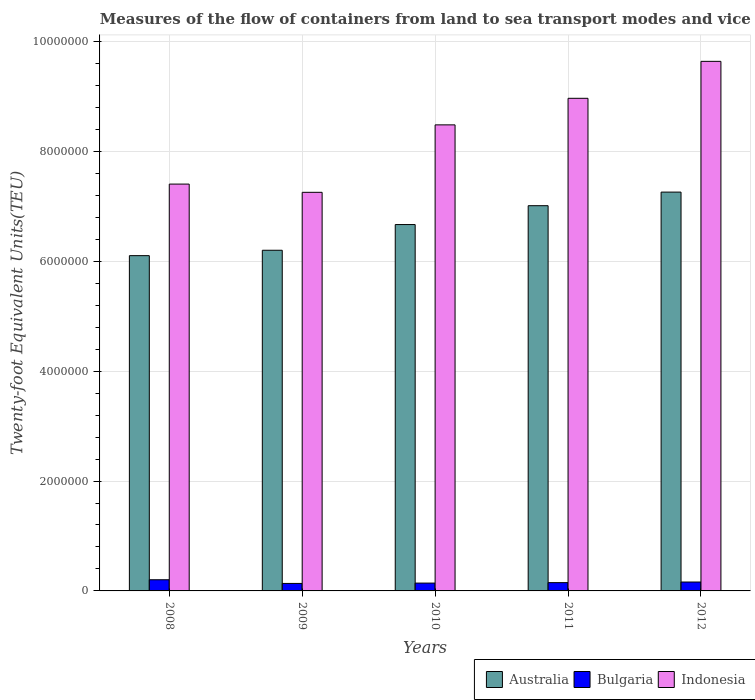Are the number of bars per tick equal to the number of legend labels?
Your response must be concise. Yes. How many bars are there on the 2nd tick from the right?
Your answer should be very brief. 3. In how many cases, is the number of bars for a given year not equal to the number of legend labels?
Your answer should be compact. 0. What is the container port traffic in Australia in 2010?
Your answer should be compact. 6.67e+06. Across all years, what is the maximum container port traffic in Australia?
Give a very brief answer. 7.26e+06. Across all years, what is the minimum container port traffic in Indonesia?
Make the answer very short. 7.26e+06. What is the total container port traffic in Australia in the graph?
Make the answer very short. 3.32e+07. What is the difference between the container port traffic in Australia in 2009 and that in 2012?
Keep it short and to the point. -1.06e+06. What is the difference between the container port traffic in Indonesia in 2011 and the container port traffic in Bulgaria in 2009?
Make the answer very short. 8.83e+06. What is the average container port traffic in Bulgaria per year?
Your response must be concise. 1.59e+05. In the year 2008, what is the difference between the container port traffic in Bulgaria and container port traffic in Indonesia?
Ensure brevity in your answer.  -7.20e+06. In how many years, is the container port traffic in Indonesia greater than 7600000 TEU?
Your answer should be compact. 3. What is the ratio of the container port traffic in Australia in 2008 to that in 2012?
Provide a short and direct response. 0.84. Is the difference between the container port traffic in Bulgaria in 2009 and 2012 greater than the difference between the container port traffic in Indonesia in 2009 and 2012?
Your response must be concise. Yes. What is the difference between the highest and the second highest container port traffic in Australia?
Give a very brief answer. 2.47e+05. What is the difference between the highest and the lowest container port traffic in Bulgaria?
Your response must be concise. 6.68e+04. In how many years, is the container port traffic in Australia greater than the average container port traffic in Australia taken over all years?
Keep it short and to the point. 3. Is the sum of the container port traffic in Indonesia in 2008 and 2010 greater than the maximum container port traffic in Bulgaria across all years?
Give a very brief answer. Yes. Is it the case that in every year, the sum of the container port traffic in Indonesia and container port traffic in Bulgaria is greater than the container port traffic in Australia?
Make the answer very short. Yes. How many bars are there?
Provide a short and direct response. 15. Are all the bars in the graph horizontal?
Provide a short and direct response. No. How many years are there in the graph?
Provide a short and direct response. 5. What is the difference between two consecutive major ticks on the Y-axis?
Your answer should be compact. 2.00e+06. Does the graph contain any zero values?
Provide a short and direct response. No. Does the graph contain grids?
Keep it short and to the point. Yes. What is the title of the graph?
Give a very brief answer. Measures of the flow of containers from land to sea transport modes and vice versa. Does "Somalia" appear as one of the legend labels in the graph?
Keep it short and to the point. No. What is the label or title of the X-axis?
Give a very brief answer. Years. What is the label or title of the Y-axis?
Make the answer very short. Twenty-foot Equivalent Units(TEU). What is the Twenty-foot Equivalent Units(TEU) of Australia in 2008?
Keep it short and to the point. 6.10e+06. What is the Twenty-foot Equivalent Units(TEU) of Bulgaria in 2008?
Your answer should be compact. 2.03e+05. What is the Twenty-foot Equivalent Units(TEU) of Indonesia in 2008?
Your answer should be compact. 7.40e+06. What is the Twenty-foot Equivalent Units(TEU) of Australia in 2009?
Keep it short and to the point. 6.20e+06. What is the Twenty-foot Equivalent Units(TEU) in Bulgaria in 2009?
Your answer should be very brief. 1.36e+05. What is the Twenty-foot Equivalent Units(TEU) in Indonesia in 2009?
Offer a very short reply. 7.26e+06. What is the Twenty-foot Equivalent Units(TEU) in Australia in 2010?
Keep it short and to the point. 6.67e+06. What is the Twenty-foot Equivalent Units(TEU) in Bulgaria in 2010?
Your answer should be very brief. 1.43e+05. What is the Twenty-foot Equivalent Units(TEU) of Indonesia in 2010?
Provide a succinct answer. 8.48e+06. What is the Twenty-foot Equivalent Units(TEU) of Australia in 2011?
Offer a very short reply. 7.01e+06. What is the Twenty-foot Equivalent Units(TEU) of Bulgaria in 2011?
Your response must be concise. 1.51e+05. What is the Twenty-foot Equivalent Units(TEU) of Indonesia in 2011?
Provide a succinct answer. 8.97e+06. What is the Twenty-foot Equivalent Units(TEU) of Australia in 2012?
Provide a short and direct response. 7.26e+06. What is the Twenty-foot Equivalent Units(TEU) of Bulgaria in 2012?
Offer a terse response. 1.62e+05. What is the Twenty-foot Equivalent Units(TEU) of Indonesia in 2012?
Make the answer very short. 9.64e+06. Across all years, what is the maximum Twenty-foot Equivalent Units(TEU) of Australia?
Offer a terse response. 7.26e+06. Across all years, what is the maximum Twenty-foot Equivalent Units(TEU) of Bulgaria?
Provide a succinct answer. 2.03e+05. Across all years, what is the maximum Twenty-foot Equivalent Units(TEU) in Indonesia?
Your answer should be very brief. 9.64e+06. Across all years, what is the minimum Twenty-foot Equivalent Units(TEU) of Australia?
Your response must be concise. 6.10e+06. Across all years, what is the minimum Twenty-foot Equivalent Units(TEU) of Bulgaria?
Give a very brief answer. 1.36e+05. Across all years, what is the minimum Twenty-foot Equivalent Units(TEU) of Indonesia?
Provide a succinct answer. 7.26e+06. What is the total Twenty-foot Equivalent Units(TEU) of Australia in the graph?
Make the answer very short. 3.32e+07. What is the total Twenty-foot Equivalent Units(TEU) of Bulgaria in the graph?
Offer a terse response. 7.95e+05. What is the total Twenty-foot Equivalent Units(TEU) of Indonesia in the graph?
Offer a terse response. 4.17e+07. What is the difference between the Twenty-foot Equivalent Units(TEU) in Australia in 2008 and that in 2009?
Offer a terse response. -9.80e+04. What is the difference between the Twenty-foot Equivalent Units(TEU) of Bulgaria in 2008 and that in 2009?
Provide a short and direct response. 6.68e+04. What is the difference between the Twenty-foot Equivalent Units(TEU) in Indonesia in 2008 and that in 2009?
Offer a very short reply. 1.50e+05. What is the difference between the Twenty-foot Equivalent Units(TEU) in Australia in 2008 and that in 2010?
Your answer should be compact. -5.66e+05. What is the difference between the Twenty-foot Equivalent Units(TEU) in Bulgaria in 2008 and that in 2010?
Keep it short and to the point. 6.06e+04. What is the difference between the Twenty-foot Equivalent Units(TEU) of Indonesia in 2008 and that in 2010?
Provide a succinct answer. -1.08e+06. What is the difference between the Twenty-foot Equivalent Units(TEU) in Australia in 2008 and that in 2011?
Keep it short and to the point. -9.09e+05. What is the difference between the Twenty-foot Equivalent Units(TEU) of Bulgaria in 2008 and that in 2011?
Make the answer very short. 5.25e+04. What is the difference between the Twenty-foot Equivalent Units(TEU) in Indonesia in 2008 and that in 2011?
Keep it short and to the point. -1.56e+06. What is the difference between the Twenty-foot Equivalent Units(TEU) in Australia in 2008 and that in 2012?
Make the answer very short. -1.16e+06. What is the difference between the Twenty-foot Equivalent Units(TEU) of Bulgaria in 2008 and that in 2012?
Make the answer very short. 4.12e+04. What is the difference between the Twenty-foot Equivalent Units(TEU) in Indonesia in 2008 and that in 2012?
Provide a succinct answer. -2.23e+06. What is the difference between the Twenty-foot Equivalent Units(TEU) of Australia in 2009 and that in 2010?
Give a very brief answer. -4.68e+05. What is the difference between the Twenty-foot Equivalent Units(TEU) in Bulgaria in 2009 and that in 2010?
Provide a succinct answer. -6167. What is the difference between the Twenty-foot Equivalent Units(TEU) in Indonesia in 2009 and that in 2010?
Offer a terse response. -1.23e+06. What is the difference between the Twenty-foot Equivalent Units(TEU) of Australia in 2009 and that in 2011?
Keep it short and to the point. -8.11e+05. What is the difference between the Twenty-foot Equivalent Units(TEU) in Bulgaria in 2009 and that in 2011?
Provide a succinct answer. -1.43e+04. What is the difference between the Twenty-foot Equivalent Units(TEU) in Indonesia in 2009 and that in 2011?
Ensure brevity in your answer.  -1.71e+06. What is the difference between the Twenty-foot Equivalent Units(TEU) of Australia in 2009 and that in 2012?
Offer a very short reply. -1.06e+06. What is the difference between the Twenty-foot Equivalent Units(TEU) of Bulgaria in 2009 and that in 2012?
Offer a terse response. -2.56e+04. What is the difference between the Twenty-foot Equivalent Units(TEU) in Indonesia in 2009 and that in 2012?
Give a very brief answer. -2.38e+06. What is the difference between the Twenty-foot Equivalent Units(TEU) of Australia in 2010 and that in 2011?
Provide a short and direct response. -3.44e+05. What is the difference between the Twenty-foot Equivalent Units(TEU) of Bulgaria in 2010 and that in 2011?
Give a very brief answer. -8128.83. What is the difference between the Twenty-foot Equivalent Units(TEU) of Indonesia in 2010 and that in 2011?
Provide a succinct answer. -4.84e+05. What is the difference between the Twenty-foot Equivalent Units(TEU) in Australia in 2010 and that in 2012?
Your answer should be very brief. -5.91e+05. What is the difference between the Twenty-foot Equivalent Units(TEU) in Bulgaria in 2010 and that in 2012?
Your answer should be compact. -1.94e+04. What is the difference between the Twenty-foot Equivalent Units(TEU) of Indonesia in 2010 and that in 2012?
Provide a short and direct response. -1.16e+06. What is the difference between the Twenty-foot Equivalent Units(TEU) of Australia in 2011 and that in 2012?
Your response must be concise. -2.47e+05. What is the difference between the Twenty-foot Equivalent Units(TEU) of Bulgaria in 2011 and that in 2012?
Your answer should be compact. -1.13e+04. What is the difference between the Twenty-foot Equivalent Units(TEU) of Indonesia in 2011 and that in 2012?
Make the answer very short. -6.72e+05. What is the difference between the Twenty-foot Equivalent Units(TEU) of Australia in 2008 and the Twenty-foot Equivalent Units(TEU) of Bulgaria in 2009?
Your response must be concise. 5.97e+06. What is the difference between the Twenty-foot Equivalent Units(TEU) in Australia in 2008 and the Twenty-foot Equivalent Units(TEU) in Indonesia in 2009?
Your answer should be very brief. -1.15e+06. What is the difference between the Twenty-foot Equivalent Units(TEU) of Bulgaria in 2008 and the Twenty-foot Equivalent Units(TEU) of Indonesia in 2009?
Ensure brevity in your answer.  -7.05e+06. What is the difference between the Twenty-foot Equivalent Units(TEU) of Australia in 2008 and the Twenty-foot Equivalent Units(TEU) of Bulgaria in 2010?
Give a very brief answer. 5.96e+06. What is the difference between the Twenty-foot Equivalent Units(TEU) of Australia in 2008 and the Twenty-foot Equivalent Units(TEU) of Indonesia in 2010?
Provide a short and direct response. -2.38e+06. What is the difference between the Twenty-foot Equivalent Units(TEU) in Bulgaria in 2008 and the Twenty-foot Equivalent Units(TEU) in Indonesia in 2010?
Keep it short and to the point. -8.28e+06. What is the difference between the Twenty-foot Equivalent Units(TEU) in Australia in 2008 and the Twenty-foot Equivalent Units(TEU) in Bulgaria in 2011?
Make the answer very short. 5.95e+06. What is the difference between the Twenty-foot Equivalent Units(TEU) in Australia in 2008 and the Twenty-foot Equivalent Units(TEU) in Indonesia in 2011?
Give a very brief answer. -2.86e+06. What is the difference between the Twenty-foot Equivalent Units(TEU) in Bulgaria in 2008 and the Twenty-foot Equivalent Units(TEU) in Indonesia in 2011?
Provide a short and direct response. -8.76e+06. What is the difference between the Twenty-foot Equivalent Units(TEU) in Australia in 2008 and the Twenty-foot Equivalent Units(TEU) in Bulgaria in 2012?
Provide a succinct answer. 5.94e+06. What is the difference between the Twenty-foot Equivalent Units(TEU) in Australia in 2008 and the Twenty-foot Equivalent Units(TEU) in Indonesia in 2012?
Give a very brief answer. -3.54e+06. What is the difference between the Twenty-foot Equivalent Units(TEU) in Bulgaria in 2008 and the Twenty-foot Equivalent Units(TEU) in Indonesia in 2012?
Give a very brief answer. -9.44e+06. What is the difference between the Twenty-foot Equivalent Units(TEU) of Australia in 2009 and the Twenty-foot Equivalent Units(TEU) of Bulgaria in 2010?
Offer a terse response. 6.06e+06. What is the difference between the Twenty-foot Equivalent Units(TEU) in Australia in 2009 and the Twenty-foot Equivalent Units(TEU) in Indonesia in 2010?
Provide a succinct answer. -2.28e+06. What is the difference between the Twenty-foot Equivalent Units(TEU) in Bulgaria in 2009 and the Twenty-foot Equivalent Units(TEU) in Indonesia in 2010?
Your answer should be very brief. -8.35e+06. What is the difference between the Twenty-foot Equivalent Units(TEU) of Australia in 2009 and the Twenty-foot Equivalent Units(TEU) of Bulgaria in 2011?
Offer a very short reply. 6.05e+06. What is the difference between the Twenty-foot Equivalent Units(TEU) of Australia in 2009 and the Twenty-foot Equivalent Units(TEU) of Indonesia in 2011?
Your response must be concise. -2.77e+06. What is the difference between the Twenty-foot Equivalent Units(TEU) of Bulgaria in 2009 and the Twenty-foot Equivalent Units(TEU) of Indonesia in 2011?
Provide a succinct answer. -8.83e+06. What is the difference between the Twenty-foot Equivalent Units(TEU) of Australia in 2009 and the Twenty-foot Equivalent Units(TEU) of Bulgaria in 2012?
Ensure brevity in your answer.  6.04e+06. What is the difference between the Twenty-foot Equivalent Units(TEU) in Australia in 2009 and the Twenty-foot Equivalent Units(TEU) in Indonesia in 2012?
Provide a short and direct response. -3.44e+06. What is the difference between the Twenty-foot Equivalent Units(TEU) of Bulgaria in 2009 and the Twenty-foot Equivalent Units(TEU) of Indonesia in 2012?
Give a very brief answer. -9.50e+06. What is the difference between the Twenty-foot Equivalent Units(TEU) in Australia in 2010 and the Twenty-foot Equivalent Units(TEU) in Bulgaria in 2011?
Provide a succinct answer. 6.52e+06. What is the difference between the Twenty-foot Equivalent Units(TEU) of Australia in 2010 and the Twenty-foot Equivalent Units(TEU) of Indonesia in 2011?
Your answer should be compact. -2.30e+06. What is the difference between the Twenty-foot Equivalent Units(TEU) of Bulgaria in 2010 and the Twenty-foot Equivalent Units(TEU) of Indonesia in 2011?
Your answer should be compact. -8.82e+06. What is the difference between the Twenty-foot Equivalent Units(TEU) in Australia in 2010 and the Twenty-foot Equivalent Units(TEU) in Bulgaria in 2012?
Ensure brevity in your answer.  6.51e+06. What is the difference between the Twenty-foot Equivalent Units(TEU) in Australia in 2010 and the Twenty-foot Equivalent Units(TEU) in Indonesia in 2012?
Your response must be concise. -2.97e+06. What is the difference between the Twenty-foot Equivalent Units(TEU) in Bulgaria in 2010 and the Twenty-foot Equivalent Units(TEU) in Indonesia in 2012?
Ensure brevity in your answer.  -9.50e+06. What is the difference between the Twenty-foot Equivalent Units(TEU) in Australia in 2011 and the Twenty-foot Equivalent Units(TEU) in Bulgaria in 2012?
Your response must be concise. 6.85e+06. What is the difference between the Twenty-foot Equivalent Units(TEU) of Australia in 2011 and the Twenty-foot Equivalent Units(TEU) of Indonesia in 2012?
Your response must be concise. -2.63e+06. What is the difference between the Twenty-foot Equivalent Units(TEU) of Bulgaria in 2011 and the Twenty-foot Equivalent Units(TEU) of Indonesia in 2012?
Your response must be concise. -9.49e+06. What is the average Twenty-foot Equivalent Units(TEU) of Australia per year?
Your answer should be compact. 6.65e+06. What is the average Twenty-foot Equivalent Units(TEU) in Bulgaria per year?
Your answer should be very brief. 1.59e+05. What is the average Twenty-foot Equivalent Units(TEU) in Indonesia per year?
Your answer should be compact. 8.35e+06. In the year 2008, what is the difference between the Twenty-foot Equivalent Units(TEU) in Australia and Twenty-foot Equivalent Units(TEU) in Bulgaria?
Give a very brief answer. 5.90e+06. In the year 2008, what is the difference between the Twenty-foot Equivalent Units(TEU) of Australia and Twenty-foot Equivalent Units(TEU) of Indonesia?
Provide a short and direct response. -1.30e+06. In the year 2008, what is the difference between the Twenty-foot Equivalent Units(TEU) of Bulgaria and Twenty-foot Equivalent Units(TEU) of Indonesia?
Your response must be concise. -7.20e+06. In the year 2009, what is the difference between the Twenty-foot Equivalent Units(TEU) in Australia and Twenty-foot Equivalent Units(TEU) in Bulgaria?
Your answer should be compact. 6.06e+06. In the year 2009, what is the difference between the Twenty-foot Equivalent Units(TEU) of Australia and Twenty-foot Equivalent Units(TEU) of Indonesia?
Offer a terse response. -1.05e+06. In the year 2009, what is the difference between the Twenty-foot Equivalent Units(TEU) of Bulgaria and Twenty-foot Equivalent Units(TEU) of Indonesia?
Offer a very short reply. -7.12e+06. In the year 2010, what is the difference between the Twenty-foot Equivalent Units(TEU) of Australia and Twenty-foot Equivalent Units(TEU) of Bulgaria?
Offer a very short reply. 6.53e+06. In the year 2010, what is the difference between the Twenty-foot Equivalent Units(TEU) of Australia and Twenty-foot Equivalent Units(TEU) of Indonesia?
Provide a short and direct response. -1.81e+06. In the year 2010, what is the difference between the Twenty-foot Equivalent Units(TEU) of Bulgaria and Twenty-foot Equivalent Units(TEU) of Indonesia?
Provide a short and direct response. -8.34e+06. In the year 2011, what is the difference between the Twenty-foot Equivalent Units(TEU) in Australia and Twenty-foot Equivalent Units(TEU) in Bulgaria?
Your answer should be very brief. 6.86e+06. In the year 2011, what is the difference between the Twenty-foot Equivalent Units(TEU) of Australia and Twenty-foot Equivalent Units(TEU) of Indonesia?
Your answer should be very brief. -1.95e+06. In the year 2011, what is the difference between the Twenty-foot Equivalent Units(TEU) in Bulgaria and Twenty-foot Equivalent Units(TEU) in Indonesia?
Keep it short and to the point. -8.82e+06. In the year 2012, what is the difference between the Twenty-foot Equivalent Units(TEU) in Australia and Twenty-foot Equivalent Units(TEU) in Bulgaria?
Your response must be concise. 7.10e+06. In the year 2012, what is the difference between the Twenty-foot Equivalent Units(TEU) in Australia and Twenty-foot Equivalent Units(TEU) in Indonesia?
Keep it short and to the point. -2.38e+06. In the year 2012, what is the difference between the Twenty-foot Equivalent Units(TEU) of Bulgaria and Twenty-foot Equivalent Units(TEU) of Indonesia?
Your response must be concise. -9.48e+06. What is the ratio of the Twenty-foot Equivalent Units(TEU) of Australia in 2008 to that in 2009?
Give a very brief answer. 0.98. What is the ratio of the Twenty-foot Equivalent Units(TEU) of Bulgaria in 2008 to that in 2009?
Give a very brief answer. 1.49. What is the ratio of the Twenty-foot Equivalent Units(TEU) in Indonesia in 2008 to that in 2009?
Make the answer very short. 1.02. What is the ratio of the Twenty-foot Equivalent Units(TEU) in Australia in 2008 to that in 2010?
Provide a succinct answer. 0.92. What is the ratio of the Twenty-foot Equivalent Units(TEU) in Bulgaria in 2008 to that in 2010?
Your answer should be very brief. 1.43. What is the ratio of the Twenty-foot Equivalent Units(TEU) of Indonesia in 2008 to that in 2010?
Your response must be concise. 0.87. What is the ratio of the Twenty-foot Equivalent Units(TEU) of Australia in 2008 to that in 2011?
Ensure brevity in your answer.  0.87. What is the ratio of the Twenty-foot Equivalent Units(TEU) of Bulgaria in 2008 to that in 2011?
Ensure brevity in your answer.  1.35. What is the ratio of the Twenty-foot Equivalent Units(TEU) of Indonesia in 2008 to that in 2011?
Your answer should be compact. 0.83. What is the ratio of the Twenty-foot Equivalent Units(TEU) in Australia in 2008 to that in 2012?
Your answer should be very brief. 0.84. What is the ratio of the Twenty-foot Equivalent Units(TEU) of Bulgaria in 2008 to that in 2012?
Your response must be concise. 1.25. What is the ratio of the Twenty-foot Equivalent Units(TEU) in Indonesia in 2008 to that in 2012?
Keep it short and to the point. 0.77. What is the ratio of the Twenty-foot Equivalent Units(TEU) of Australia in 2009 to that in 2010?
Your answer should be very brief. 0.93. What is the ratio of the Twenty-foot Equivalent Units(TEU) in Bulgaria in 2009 to that in 2010?
Offer a very short reply. 0.96. What is the ratio of the Twenty-foot Equivalent Units(TEU) in Indonesia in 2009 to that in 2010?
Give a very brief answer. 0.86. What is the ratio of the Twenty-foot Equivalent Units(TEU) of Australia in 2009 to that in 2011?
Your answer should be very brief. 0.88. What is the ratio of the Twenty-foot Equivalent Units(TEU) in Bulgaria in 2009 to that in 2011?
Your response must be concise. 0.91. What is the ratio of the Twenty-foot Equivalent Units(TEU) in Indonesia in 2009 to that in 2011?
Keep it short and to the point. 0.81. What is the ratio of the Twenty-foot Equivalent Units(TEU) of Australia in 2009 to that in 2012?
Your answer should be very brief. 0.85. What is the ratio of the Twenty-foot Equivalent Units(TEU) in Bulgaria in 2009 to that in 2012?
Keep it short and to the point. 0.84. What is the ratio of the Twenty-foot Equivalent Units(TEU) of Indonesia in 2009 to that in 2012?
Keep it short and to the point. 0.75. What is the ratio of the Twenty-foot Equivalent Units(TEU) in Australia in 2010 to that in 2011?
Give a very brief answer. 0.95. What is the ratio of the Twenty-foot Equivalent Units(TEU) in Bulgaria in 2010 to that in 2011?
Your answer should be very brief. 0.95. What is the ratio of the Twenty-foot Equivalent Units(TEU) in Indonesia in 2010 to that in 2011?
Offer a very short reply. 0.95. What is the ratio of the Twenty-foot Equivalent Units(TEU) of Australia in 2010 to that in 2012?
Your answer should be very brief. 0.92. What is the ratio of the Twenty-foot Equivalent Units(TEU) of Bulgaria in 2010 to that in 2012?
Your answer should be very brief. 0.88. What is the ratio of the Twenty-foot Equivalent Units(TEU) in Indonesia in 2010 to that in 2012?
Offer a terse response. 0.88. What is the ratio of the Twenty-foot Equivalent Units(TEU) in Australia in 2011 to that in 2012?
Provide a succinct answer. 0.97. What is the ratio of the Twenty-foot Equivalent Units(TEU) in Bulgaria in 2011 to that in 2012?
Your response must be concise. 0.93. What is the ratio of the Twenty-foot Equivalent Units(TEU) in Indonesia in 2011 to that in 2012?
Keep it short and to the point. 0.93. What is the difference between the highest and the second highest Twenty-foot Equivalent Units(TEU) of Australia?
Keep it short and to the point. 2.47e+05. What is the difference between the highest and the second highest Twenty-foot Equivalent Units(TEU) of Bulgaria?
Ensure brevity in your answer.  4.12e+04. What is the difference between the highest and the second highest Twenty-foot Equivalent Units(TEU) of Indonesia?
Your answer should be very brief. 6.72e+05. What is the difference between the highest and the lowest Twenty-foot Equivalent Units(TEU) of Australia?
Ensure brevity in your answer.  1.16e+06. What is the difference between the highest and the lowest Twenty-foot Equivalent Units(TEU) in Bulgaria?
Keep it short and to the point. 6.68e+04. What is the difference between the highest and the lowest Twenty-foot Equivalent Units(TEU) in Indonesia?
Your answer should be compact. 2.38e+06. 